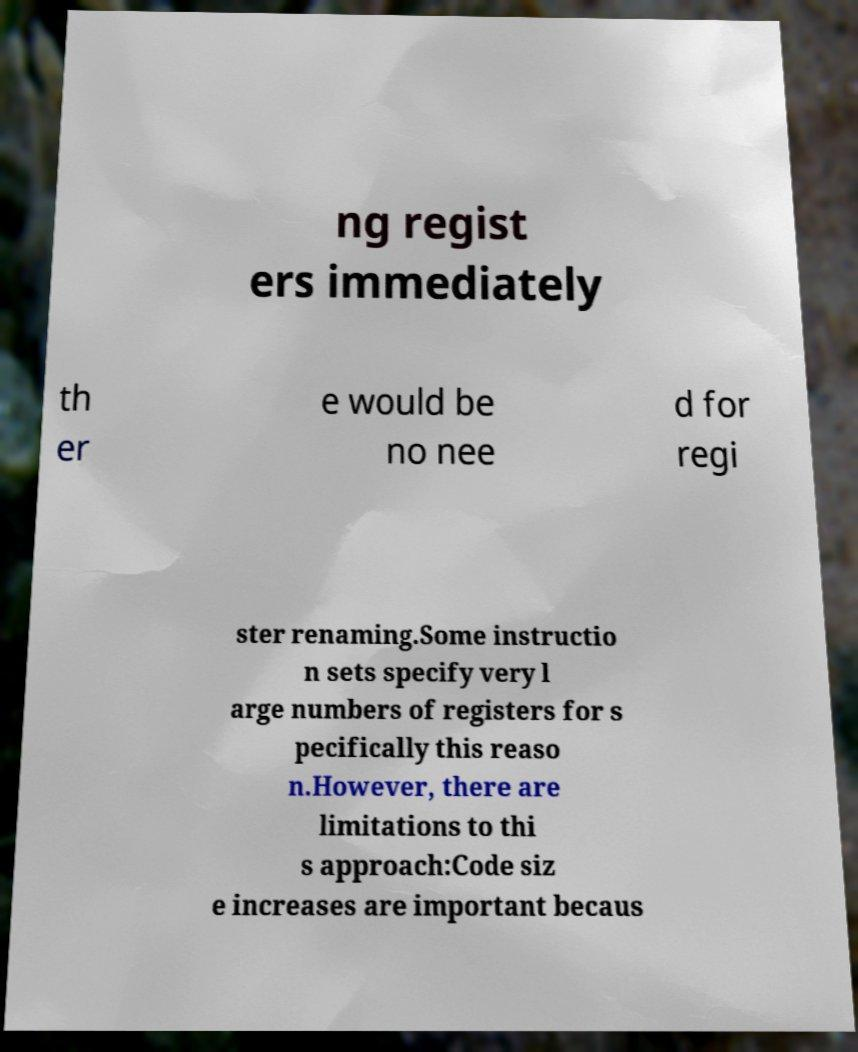Could you extract and type out the text from this image? ng regist ers immediately th er e would be no nee d for regi ster renaming.Some instructio n sets specify very l arge numbers of registers for s pecifically this reaso n.However, there are limitations to thi s approach:Code siz e increases are important becaus 